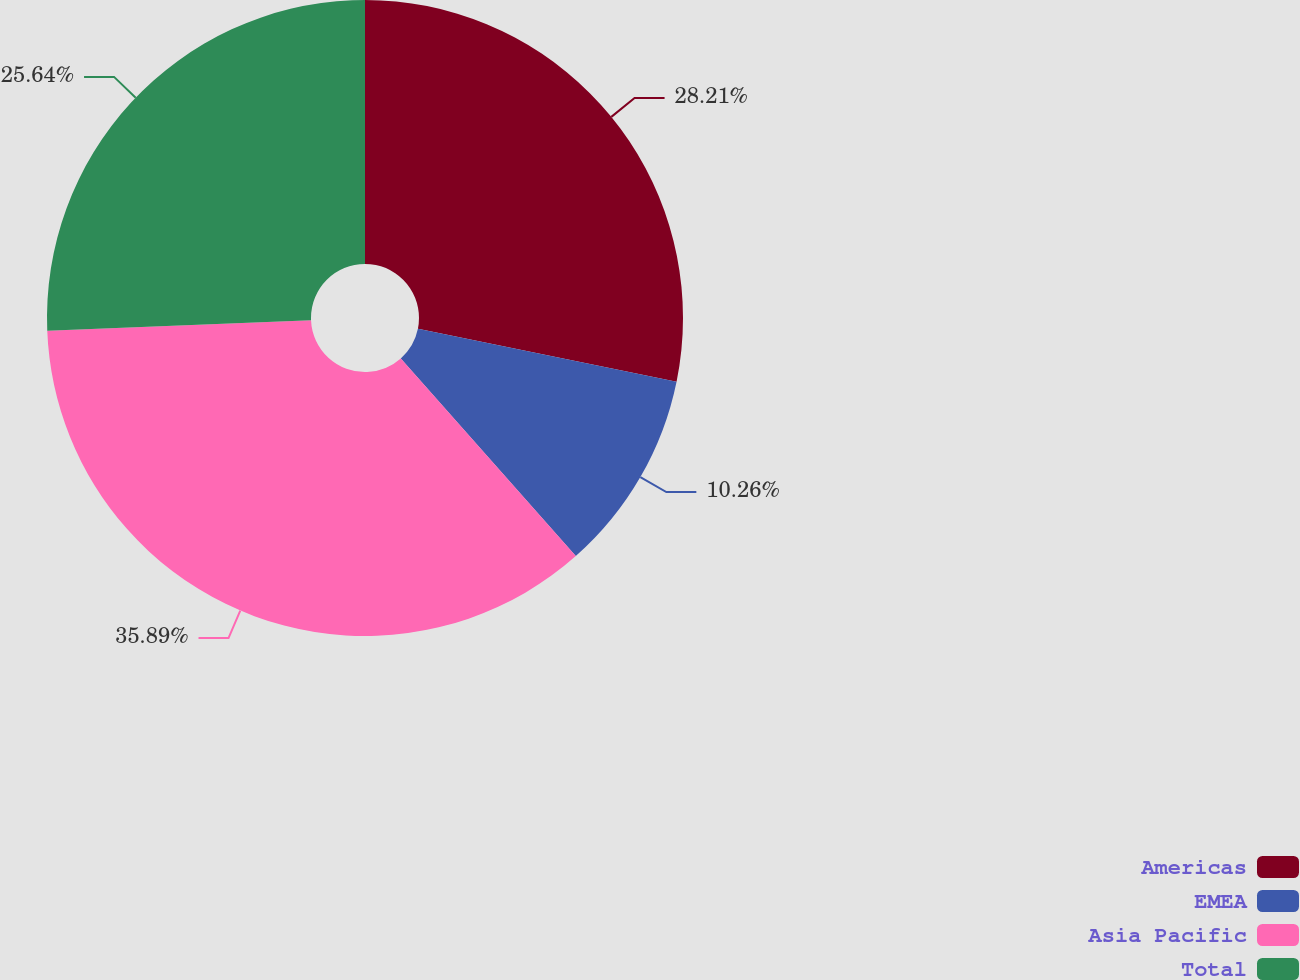<chart> <loc_0><loc_0><loc_500><loc_500><pie_chart><fcel>Americas<fcel>EMEA<fcel>Asia Pacific<fcel>Total<nl><fcel>28.21%<fcel>10.26%<fcel>35.9%<fcel>25.64%<nl></chart> 